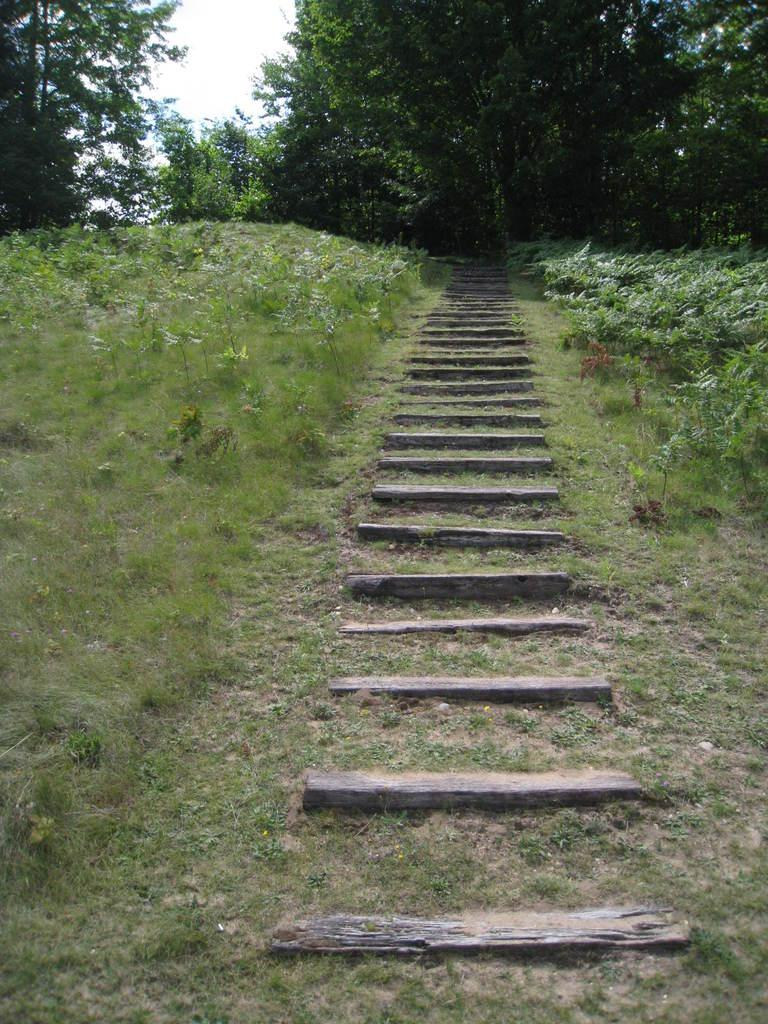What geographical feature is the main subject of the image? There is a hill in the image. What can be found on the hill? There are plants and grass on the hill. Are there any man-made structures on the hill? Yes, there are steps in the center of the hill. What is visible in the background of the image? There are trees in the background of the image. What is visible at the top of the image? The sky is visible at the top of the image. What type of polish is being applied to the trees in the image? There is no indication in the image that any polish is being applied to the trees. 